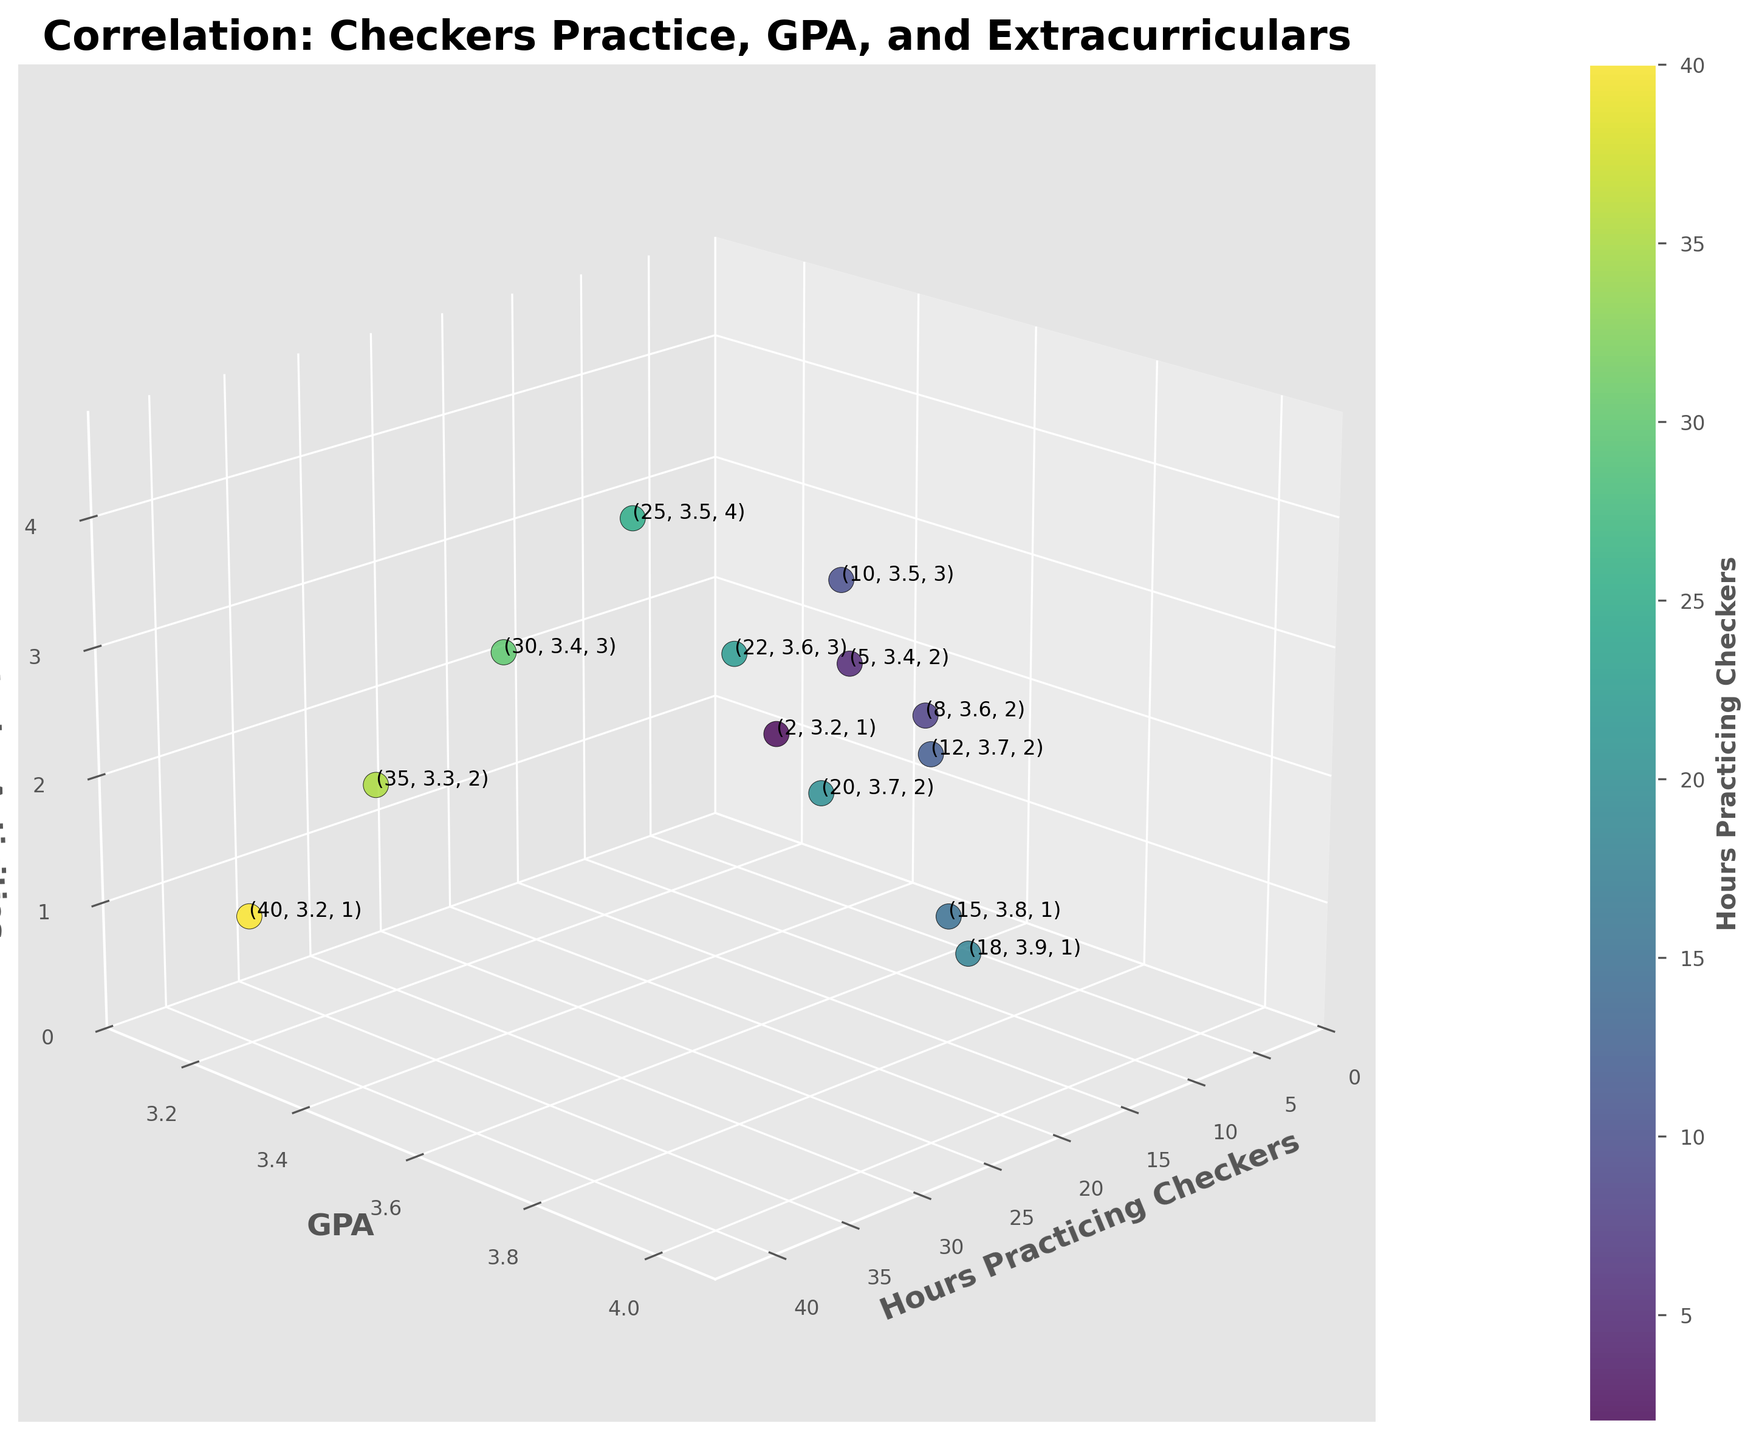what is the title of the plot? The title of the plot is found at the top of the figure, displayed in bold text.
Answer: Correlation: Checkers Practice, GPA, and Extracurriculars Which axis represents GPA? The GPA axis is labeled clearly along the y-axis with 'GPA' in bold text.
Answer: y-axis How many data points are plotted? Each data point represents an entry from the data set. They can be counted visually from the scatter plot.
Answer: 13 What are the minimum and maximum hours spent practicing checkers in the plot? The minimum and maximum values can be found by examining the range of the x-axis along with the labels and markers on the axis.
Answer: Min: 2, Max: 40 How many extracurricular activities did the student practice for 30 hours of checkers? Locate the data point at 30 hours on the x-axis, then move down vertically to see the value on the z-axis.
Answer: 3 What GPA corresponds to practicing checkers for 10 hours? Locate the data point at 10 hours on the x-axis, then move horizontally to see the value on the y-axis.
Answer: 3.5 Which data point has the highest GPA, and how many hours of checkers does it represent? Find the highest point along the y-axis and then trace it back to the corresponding x-axis value.
Answer: Highest GPA: 3.9, Hours: 18 How does GPA change as hours practicing checkers increases beyond 20 hours? Observe the trend of the data points on the y-axis as the x-axis values increase beyond 20 hours.
Answer: It decreases What is the average GPA for students practicing checkers up to 20 hours? Calculate the GPA for data points with x-values from 0 to 20, then find their average. (3.2 + 3.4 + 3.6 + 3.5 + 3.7 + 3.8 + 3.9) / 7 = 3.586
Answer: 3.586 Does participation in more extracurricular activities correlate positively or negatively with GPA for students practicing more than 20 hours? Examine the z and y values for data points where x is more than 20 hours. Compare GPA values with the number of extracurricular activities.
Answer: Negatively 